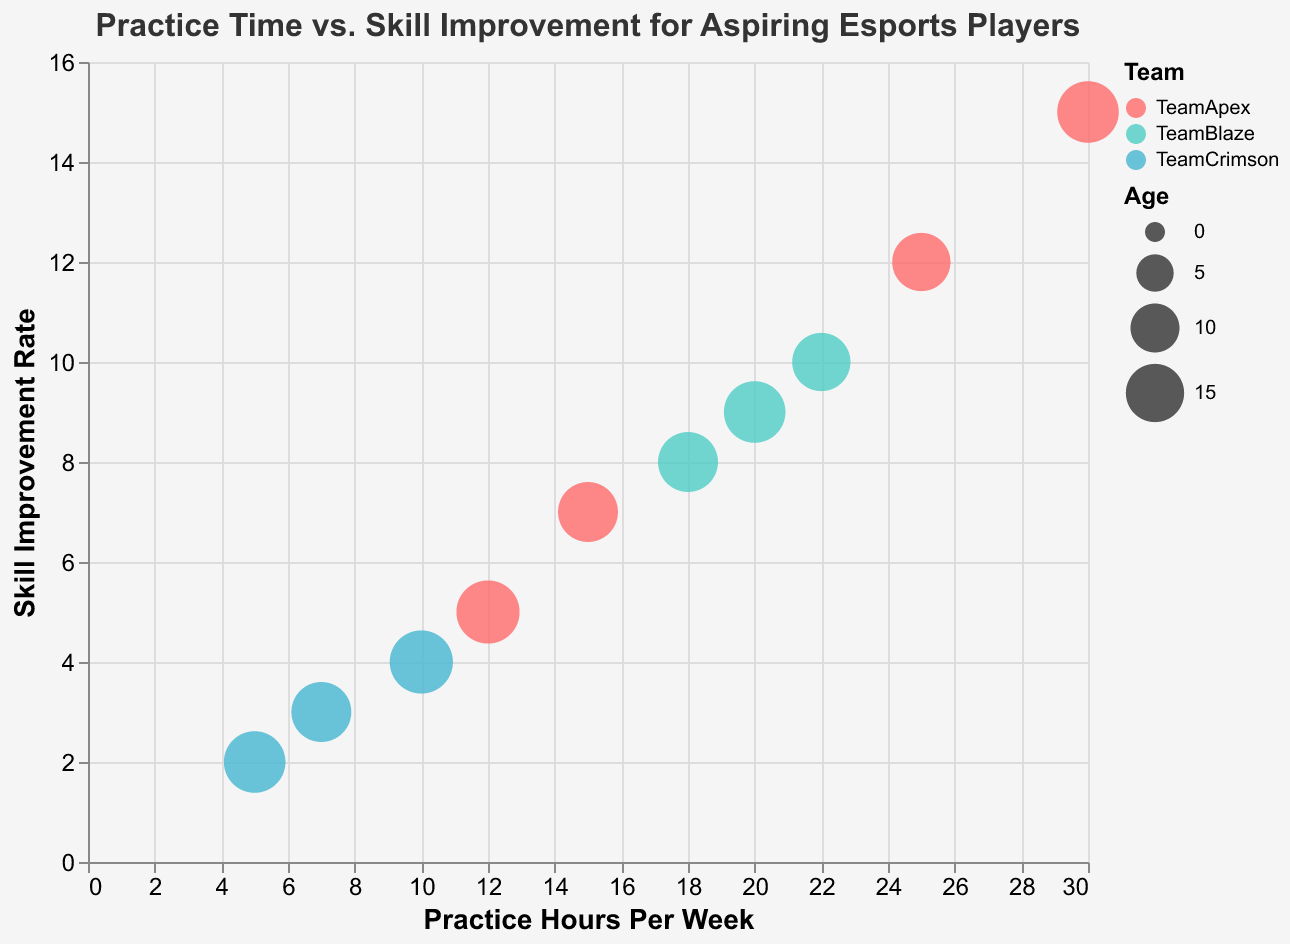What is the title of the chart? The title is visible at the top of the chart and describes the main focus of the data visualization.
Answer: Practice Time vs. Skill Improvement for Aspiring Esports Players How many data points are represented in the bubble chart? There are 10 different players with unique practice hours and skill improvement data points represented by circles.
Answer: 10 Which player has the highest skill improvement rate? By looking at the y-axis, the highest skill improvement rate value is 15 belonging to Lucas Martinez.
Answer: Lucas Martinez Which team has the most players represented in the chart? There are three different teams with multiple players. By counting the occurrences, Team Apex has the most players.
Answer: Team Apex Do older players correlate with higher practice hours per week? Look at the size (age) of the bubbles along the x-axis (practice hours). Generally, larger bubbles are not consistently at higher practice hours.
Answer: No What is the difference in practice hours per week between the player with the highest and lowest skill improvement rates? Lucas Martinez practices 30 hours per week and Emma Davis practices 5 hours per week. The difference is 30 - 5.
Answer: 25 hours Identify the player with the youngest age and their corresponding practice hours per week. The bubble's size indicates age. Maria Garcia and Sophia Wilson are both the youngest (15 years) and practice 25 and 22 hours per week, respectively.
Answer: Maria Garcia (25 hours), Sophia Wilson (22 hours) How many players improve their skills by 10 units or more per week? Skill improvement rate is on the y-axis. Lucas Martinez, Maria Garcia, and Sophia Wilson have rates of 15, 12, and 10, respectively.
Answer: 3 players Which team shows a wider range of practice hours per week among its players? Analyzing the spread of data points of each color, Team Apex (represented by red) shows a wider range from 12 to 30 hours.
Answer: Team Apex Is there a clear correlation between practice hours and skill improvement rate? By observing the general trend in the data points, there is an upward trend indicating more practice hours correlate with higher skill improvement rates.
Answer: Yes 